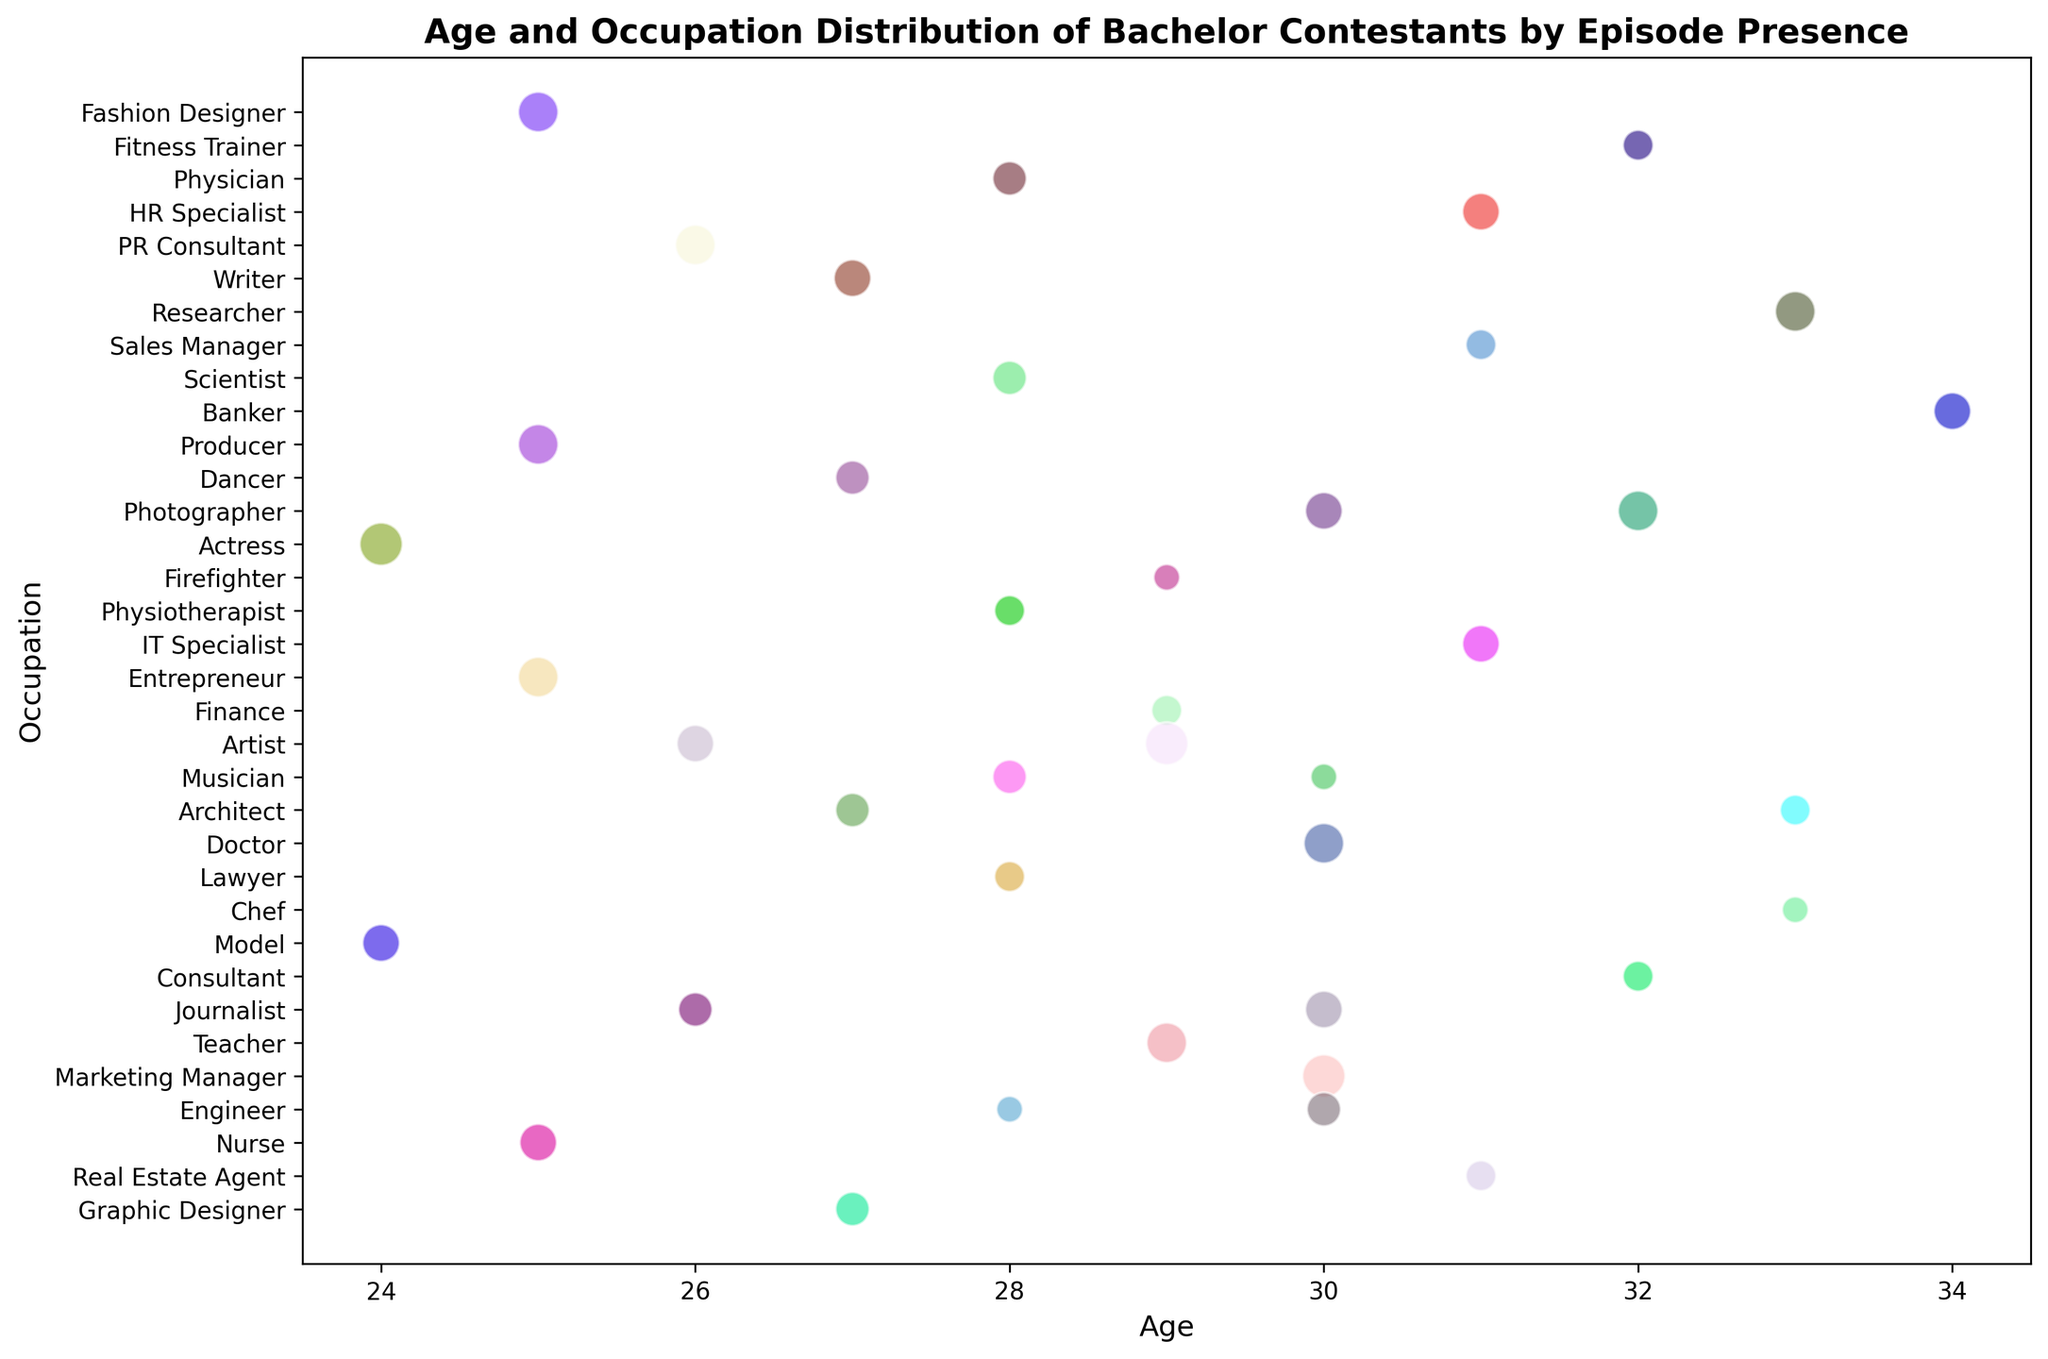Which age group has the smallest number of occupations present? Look at the x-axis (Age) and identify the number of different occupations for each age group by the bubbles present vertically. The minimum number of unique bubbles corresponds to the age group with the fewest occupations.
Answer: 24 What is the most common occupation among contestants aged between 27 and 29? Consider the x-axis range from 27 to 29 and observe which occupation appears most frequently between these values. Count the number of bubbles for each occupation in that age span.
Answer: Artist How does the presence of 'Doctors' compare to that of 'Nurses'? Locate the 'Doctor' and 'Nurse' bubbles on the y-axis (Occupation) and compare their bubble sizes, which represent the number of episodes they appeared in.
Answer: Doctor: 7 episodes, Nurse: 6 episodes Which occupation has the highest average age of contestants? For each occupation bubble, note the age from the x-axis and compute the average value for each occupation. Select the highest value among these averages.
Answer: Researcher In which age group do we see the highest number of contestants with low episode presence (3-4 episodes)? Identify the range on the x-axis where multiple small-sized bubbles (indicating 3-4 episode presence) are clustered together.
Answer: 30 How many contestants are there in the age group 31-33 with an episode presence of 4 or more? Look at ages 31 to 33 on the x-axis and count the bubbles that have a size corresponding to an episode presence of 4 or more.
Answer: 5 What color generally represents occupations with high episode presence values (7-8 episodes)? Identify the colors of the largest-sized bubbles as they correspond to higher episode values (7-8). Note the most frequently occurring color among these bubbles.
Answer: Red (for example) Does the data show any clusters of a specific occupation in a narrow age range? Observe if any single occupation has multiple bubbles tightly packed in a narrow age range along the x-axis. This indicates clustering.
Answer: Artist at 26-27 Which two occupations show a significant difference in average episode presence? Calculate the average episode presence (bubble size) for various occupations and identify two occupations with a noticeable difference between their averages.
Answer: Model (6) vs. Engineer (4) Is there an occupation that appears only once in the youngest age group displayed? If so, what is it? Check the bubbles at the lowest end of the x-axis (youngest age) and see if an occupation is represented by only one bubble.
Answer: Model at age 24 